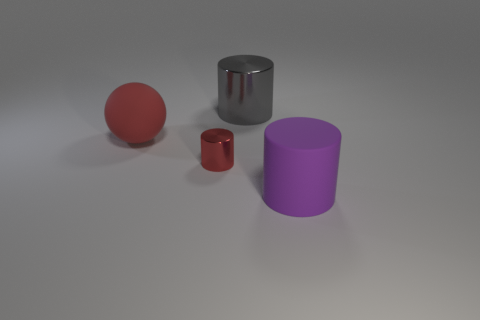Can you describe the objects seen in the image and their arrangement? Certainly, the image displays four objects on a flat surface with a neutral background. From left to right, we see a red sphere, a smaller red cylinder, a larger silver cylinder, and a larger purple cylinder. They appear to be evenly spaced and arranged in a horizontal line, casting soft shadows on the surface below due to the lighting above. 